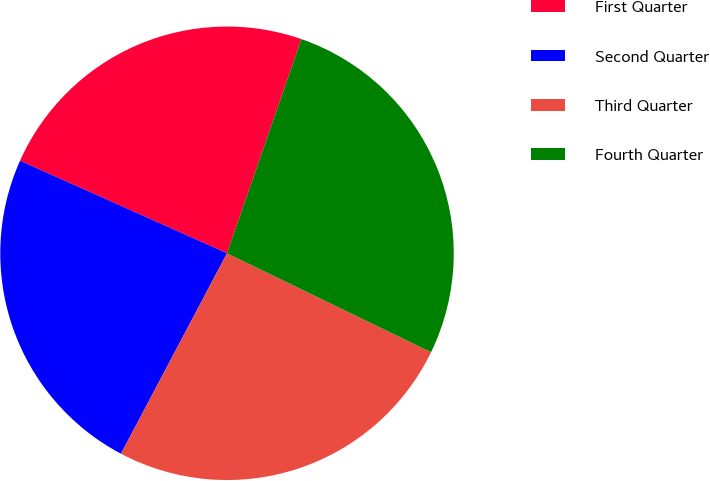<chart> <loc_0><loc_0><loc_500><loc_500><pie_chart><fcel>First Quarter<fcel>Second Quarter<fcel>Third Quarter<fcel>Fourth Quarter<nl><fcel>23.63%<fcel>23.95%<fcel>25.56%<fcel>26.86%<nl></chart> 